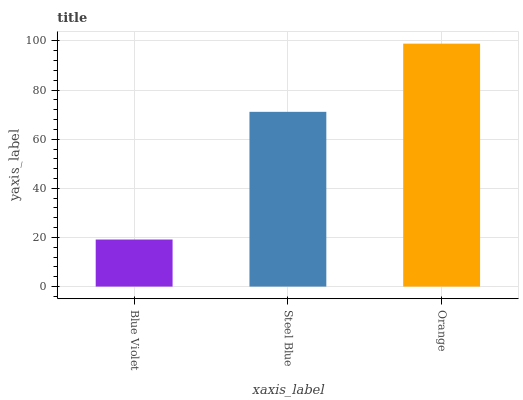Is Blue Violet the minimum?
Answer yes or no. Yes. Is Orange the maximum?
Answer yes or no. Yes. Is Steel Blue the minimum?
Answer yes or no. No. Is Steel Blue the maximum?
Answer yes or no. No. Is Steel Blue greater than Blue Violet?
Answer yes or no. Yes. Is Blue Violet less than Steel Blue?
Answer yes or no. Yes. Is Blue Violet greater than Steel Blue?
Answer yes or no. No. Is Steel Blue less than Blue Violet?
Answer yes or no. No. Is Steel Blue the high median?
Answer yes or no. Yes. Is Steel Blue the low median?
Answer yes or no. Yes. Is Blue Violet the high median?
Answer yes or no. No. Is Blue Violet the low median?
Answer yes or no. No. 